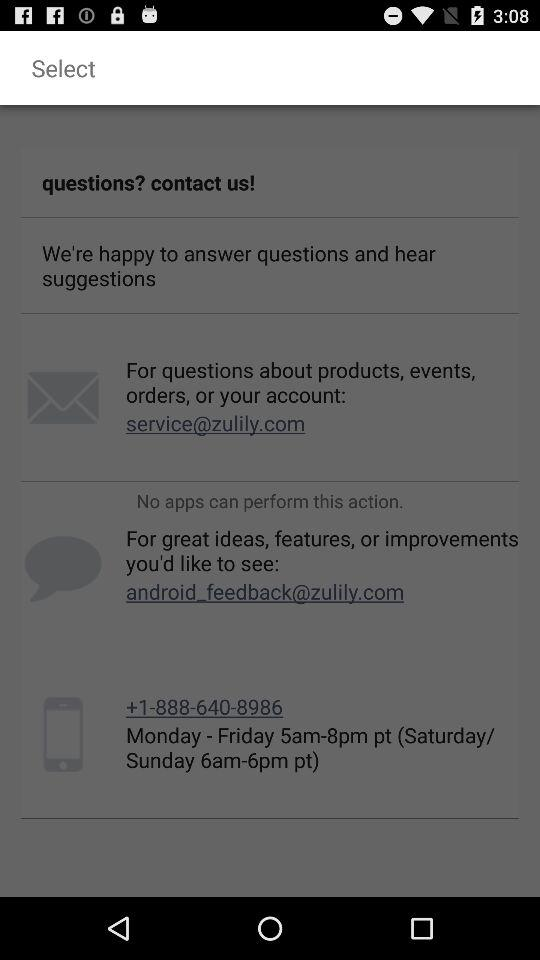How many contact options are available?
Answer the question using a single word or phrase. 3 